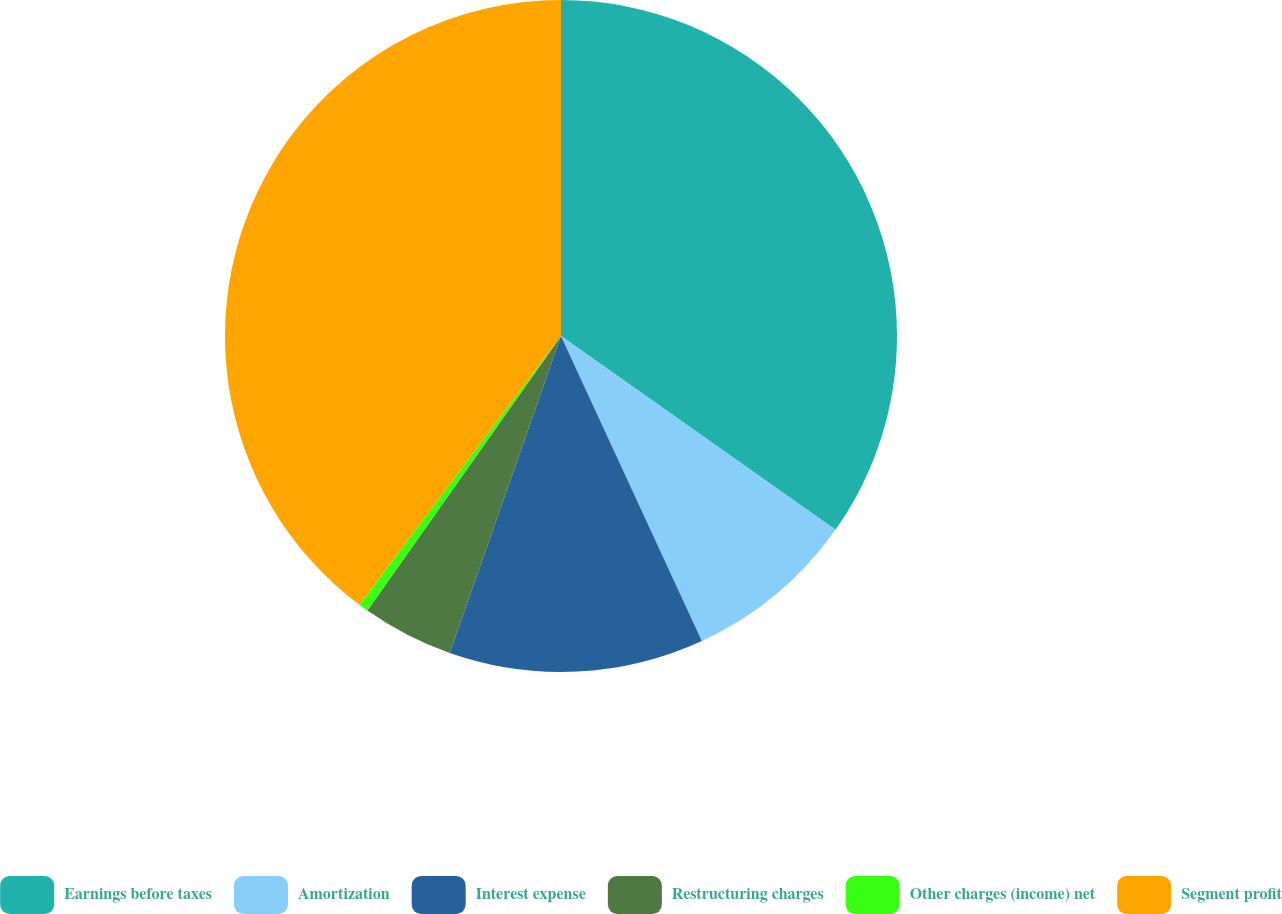Convert chart to OTSL. <chart><loc_0><loc_0><loc_500><loc_500><pie_chart><fcel>Earnings before taxes<fcel>Amortization<fcel>Interest expense<fcel>Restructuring charges<fcel>Other charges (income) net<fcel>Segment profit<nl><fcel>34.79%<fcel>8.33%<fcel>12.26%<fcel>4.4%<fcel>0.47%<fcel>39.76%<nl></chart> 